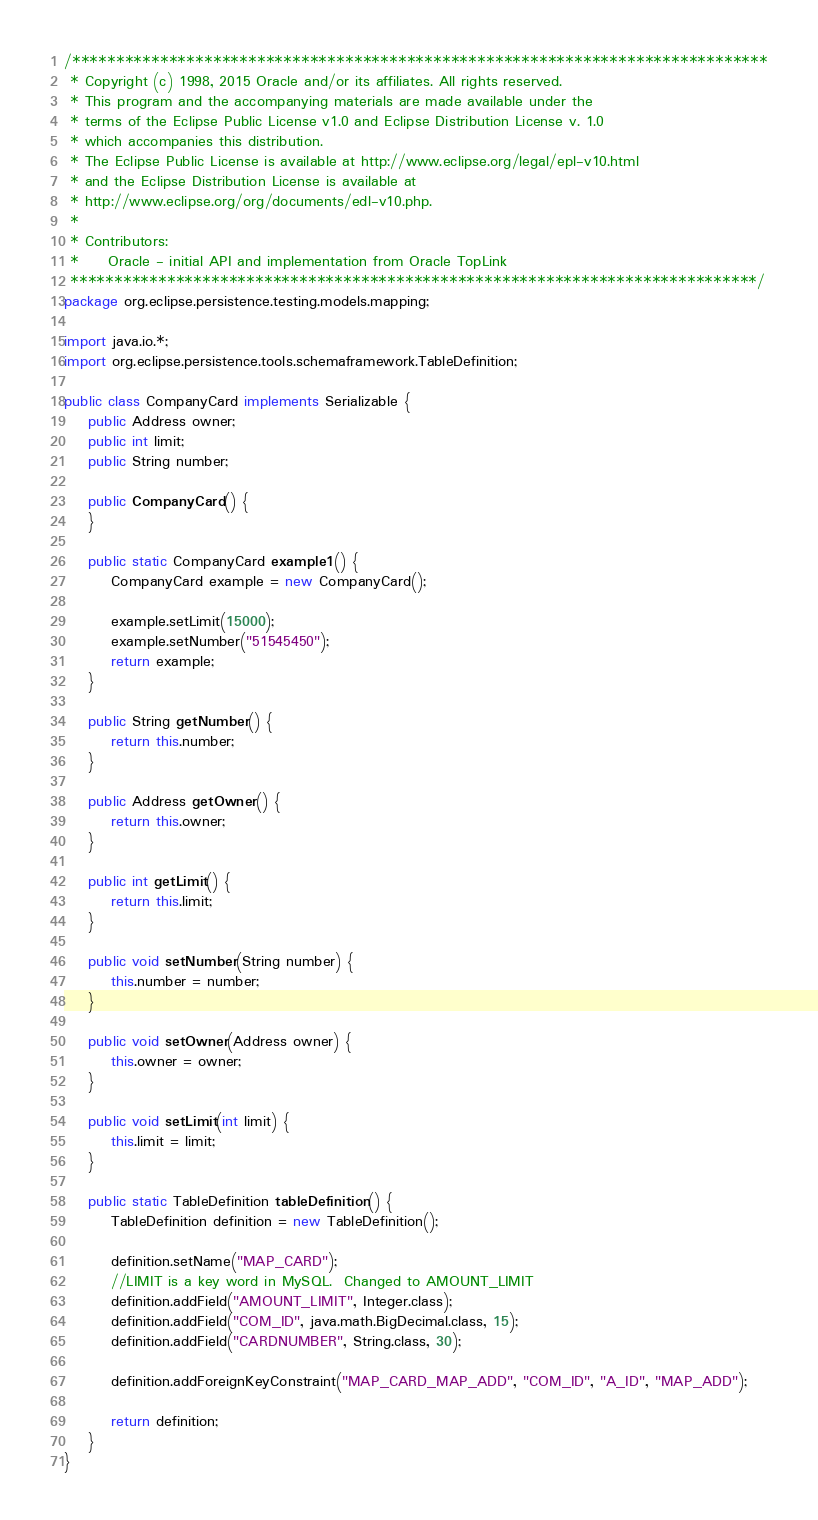<code> <loc_0><loc_0><loc_500><loc_500><_Java_>/*******************************************************************************
 * Copyright (c) 1998, 2015 Oracle and/or its affiliates. All rights reserved.
 * This program and the accompanying materials are made available under the
 * terms of the Eclipse Public License v1.0 and Eclipse Distribution License v. 1.0
 * which accompanies this distribution.
 * The Eclipse Public License is available at http://www.eclipse.org/legal/epl-v10.html
 * and the Eclipse Distribution License is available at
 * http://www.eclipse.org/org/documents/edl-v10.php.
 *
 * Contributors:
 *     Oracle - initial API and implementation from Oracle TopLink
 ******************************************************************************/
package org.eclipse.persistence.testing.models.mapping;

import java.io.*;
import org.eclipse.persistence.tools.schemaframework.TableDefinition;

public class CompanyCard implements Serializable {
    public Address owner;
    public int limit;
    public String number;

    public CompanyCard() {
    }

    public static CompanyCard example1() {
        CompanyCard example = new CompanyCard();

        example.setLimit(15000);
        example.setNumber("51545450");
        return example;
    }

    public String getNumber() {
        return this.number;
    }

    public Address getOwner() {
        return this.owner;
    }

    public int getLimit() {
        return this.limit;
    }

    public void setNumber(String number) {
        this.number = number;
    }

    public void setOwner(Address owner) {
        this.owner = owner;
    }

    public void setLimit(int limit) {
        this.limit = limit;
    }

    public static TableDefinition tableDefinition() {
        TableDefinition definition = new TableDefinition();

        definition.setName("MAP_CARD");
        //LIMIT is a key word in MySQL.  Changed to AMOUNT_LIMIT
        definition.addField("AMOUNT_LIMIT", Integer.class);
        definition.addField("COM_ID", java.math.BigDecimal.class, 15);
        definition.addField("CARDNUMBER", String.class, 30);

        definition.addForeignKeyConstraint("MAP_CARD_MAP_ADD", "COM_ID", "A_ID", "MAP_ADD");

        return definition;
    }
}
</code> 